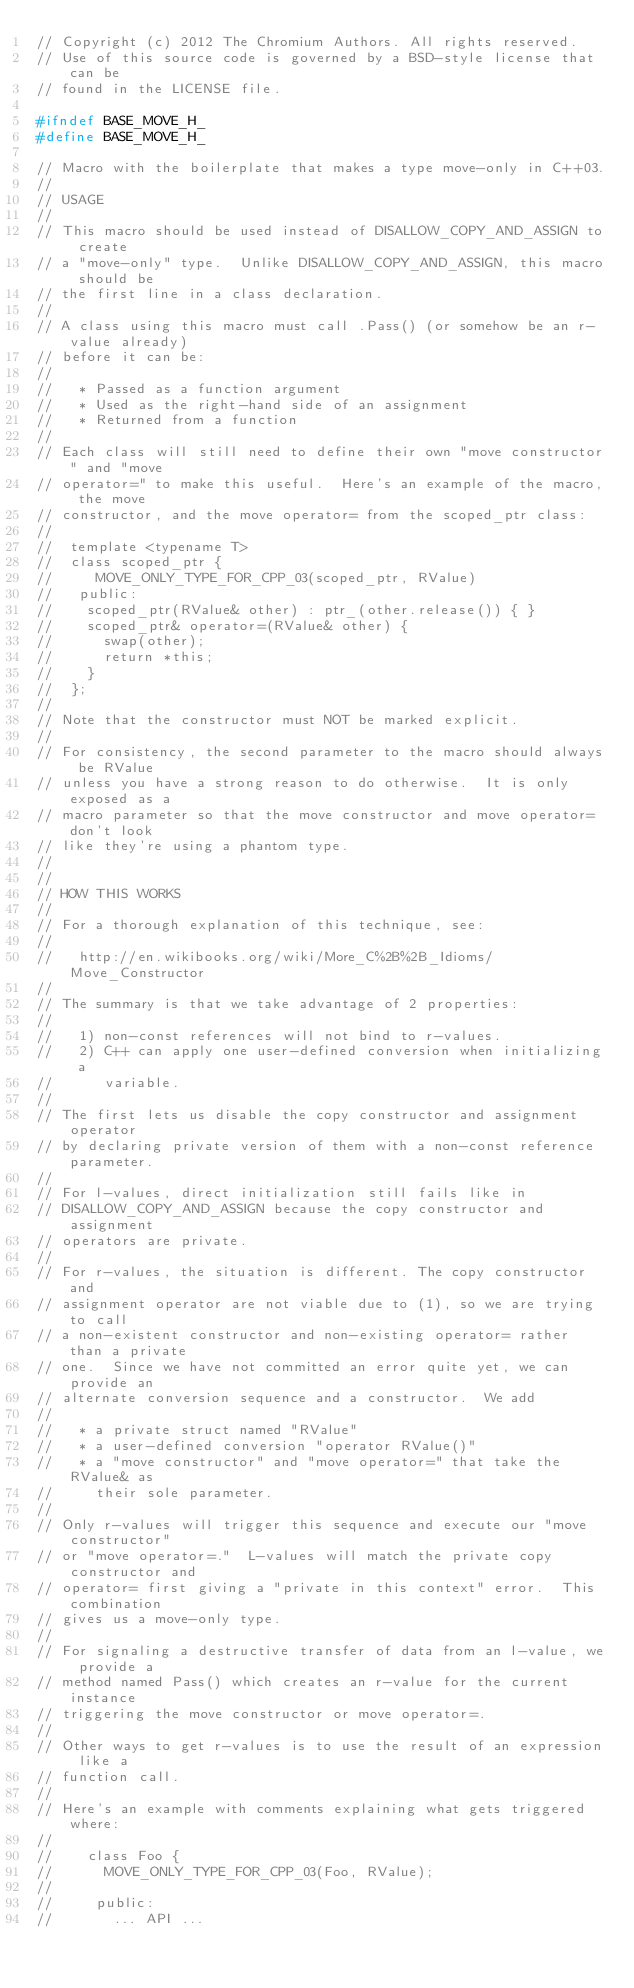Convert code to text. <code><loc_0><loc_0><loc_500><loc_500><_C_>// Copyright (c) 2012 The Chromium Authors. All rights reserved.
// Use of this source code is governed by a BSD-style license that can be
// found in the LICENSE file.

#ifndef BASE_MOVE_H_
#define BASE_MOVE_H_

// Macro with the boilerplate that makes a type move-only in C++03.
//
// USAGE
//
// This macro should be used instead of DISALLOW_COPY_AND_ASSIGN to create
// a "move-only" type.  Unlike DISALLOW_COPY_AND_ASSIGN, this macro should be
// the first line in a class declaration.
//
// A class using this macro must call .Pass() (or somehow be an r-value already)
// before it can be:
//
//   * Passed as a function argument
//   * Used as the right-hand side of an assignment
//   * Returned from a function
//
// Each class will still need to define their own "move constructor" and "move
// operator=" to make this useful.  Here's an example of the macro, the move
// constructor, and the move operator= from the scoped_ptr class:
//
//  template <typename T>
//  class scoped_ptr {
//     MOVE_ONLY_TYPE_FOR_CPP_03(scoped_ptr, RValue)
//   public:
//    scoped_ptr(RValue& other) : ptr_(other.release()) { }
//    scoped_ptr& operator=(RValue& other) {
//      swap(other);
//      return *this;
//    }
//  };
//
// Note that the constructor must NOT be marked explicit.
//
// For consistency, the second parameter to the macro should always be RValue
// unless you have a strong reason to do otherwise.  It is only exposed as a
// macro parameter so that the move constructor and move operator= don't look
// like they're using a phantom type.
//
//
// HOW THIS WORKS
//
// For a thorough explanation of this technique, see:
//
//   http://en.wikibooks.org/wiki/More_C%2B%2B_Idioms/Move_Constructor
//
// The summary is that we take advantage of 2 properties:
//
//   1) non-const references will not bind to r-values.
//   2) C++ can apply one user-defined conversion when initializing a
//      variable.
//
// The first lets us disable the copy constructor and assignment operator
// by declaring private version of them with a non-const reference parameter.
//
// For l-values, direct initialization still fails like in
// DISALLOW_COPY_AND_ASSIGN because the copy constructor and assignment
// operators are private.
//
// For r-values, the situation is different. The copy constructor and
// assignment operator are not viable due to (1), so we are trying to call
// a non-existent constructor and non-existing operator= rather than a private
// one.  Since we have not committed an error quite yet, we can provide an
// alternate conversion sequence and a constructor.  We add
//
//   * a private struct named "RValue"
//   * a user-defined conversion "operator RValue()"
//   * a "move constructor" and "move operator=" that take the RValue& as
//     their sole parameter.
//
// Only r-values will trigger this sequence and execute our "move constructor"
// or "move operator=."  L-values will match the private copy constructor and
// operator= first giving a "private in this context" error.  This combination
// gives us a move-only type.
//
// For signaling a destructive transfer of data from an l-value, we provide a
// method named Pass() which creates an r-value for the current instance
// triggering the move constructor or move operator=.
//
// Other ways to get r-values is to use the result of an expression like a
// function call.
//
// Here's an example with comments explaining what gets triggered where:
//
//    class Foo {
//      MOVE_ONLY_TYPE_FOR_CPP_03(Foo, RValue);
//
//     public:
//       ... API ...</code> 